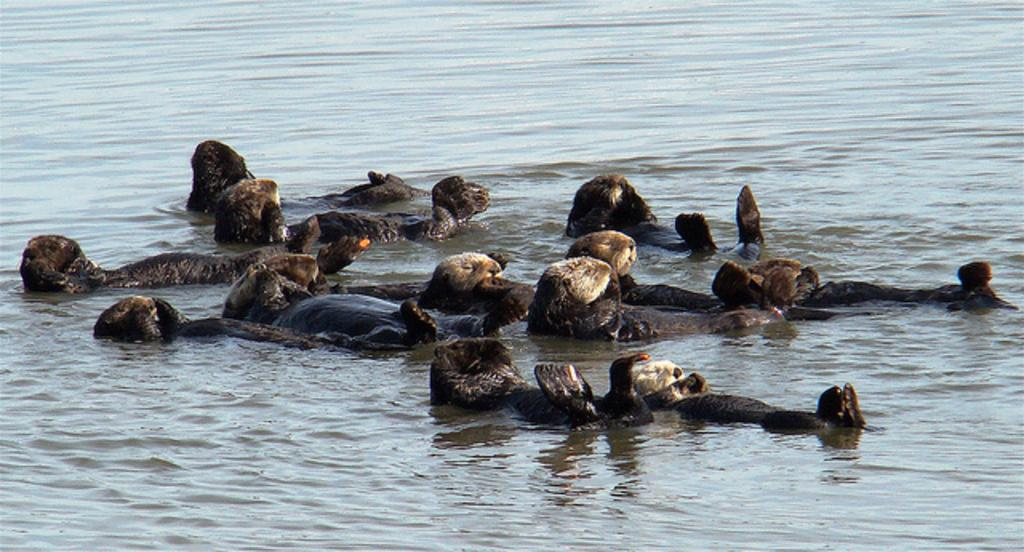What type of animals can be seen in the image? There are animals in the water in the image. Can you describe the setting where the animals are located? The animals are in the water, which suggests they might be aquatic or swimming. What might the animals be doing in the water? The animals could be swimming, playing, or feeding in the water. What type of tree can be seen growing in the water in the image? There is no tree present in the image; it features animals in the water. How many cherries can be seen floating in the water in the image? There are no cherries present in the image; it features animals in the water. 